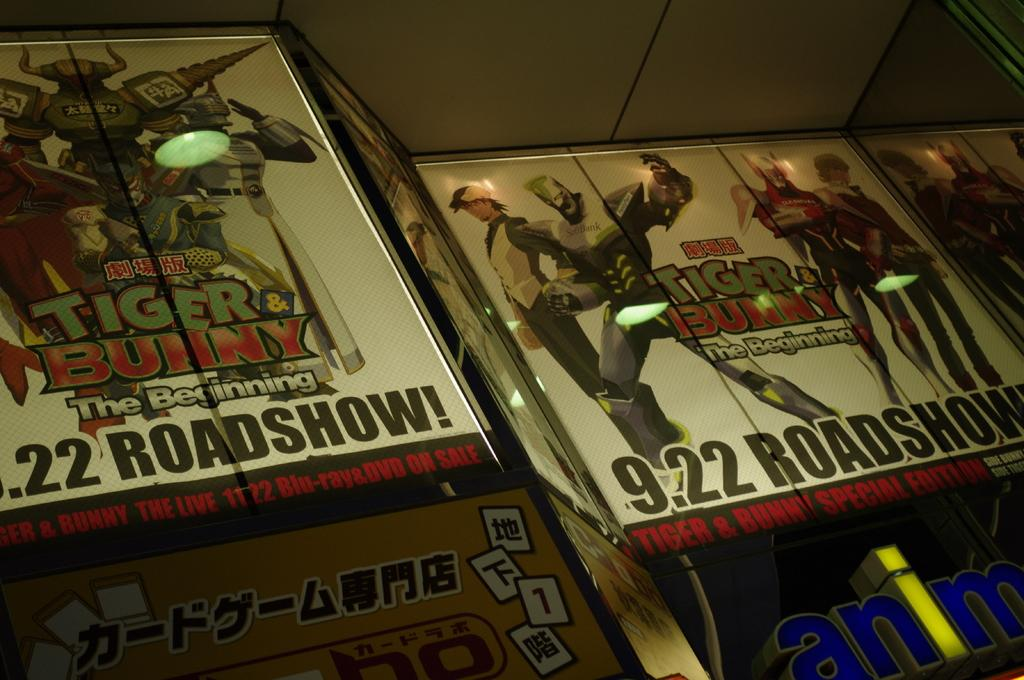<image>
Write a terse but informative summary of the picture. Advertisement for Tiger Bunny that takes place on 9 22. 